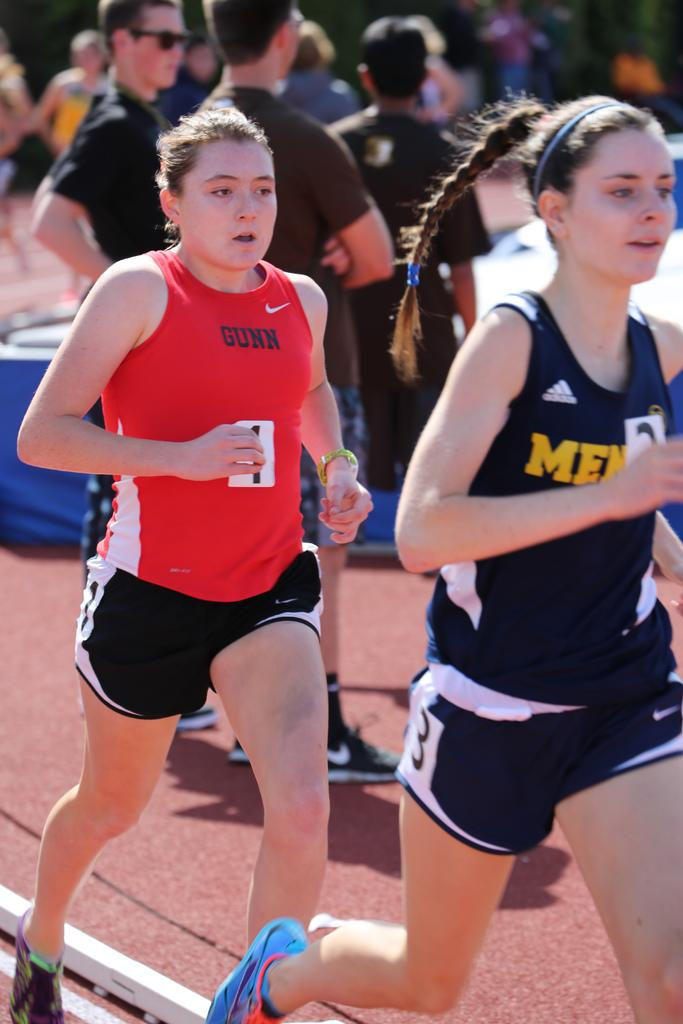<image>
Describe the image concisely. A woman running wearing a red Nike shirt that says gunn on it. 